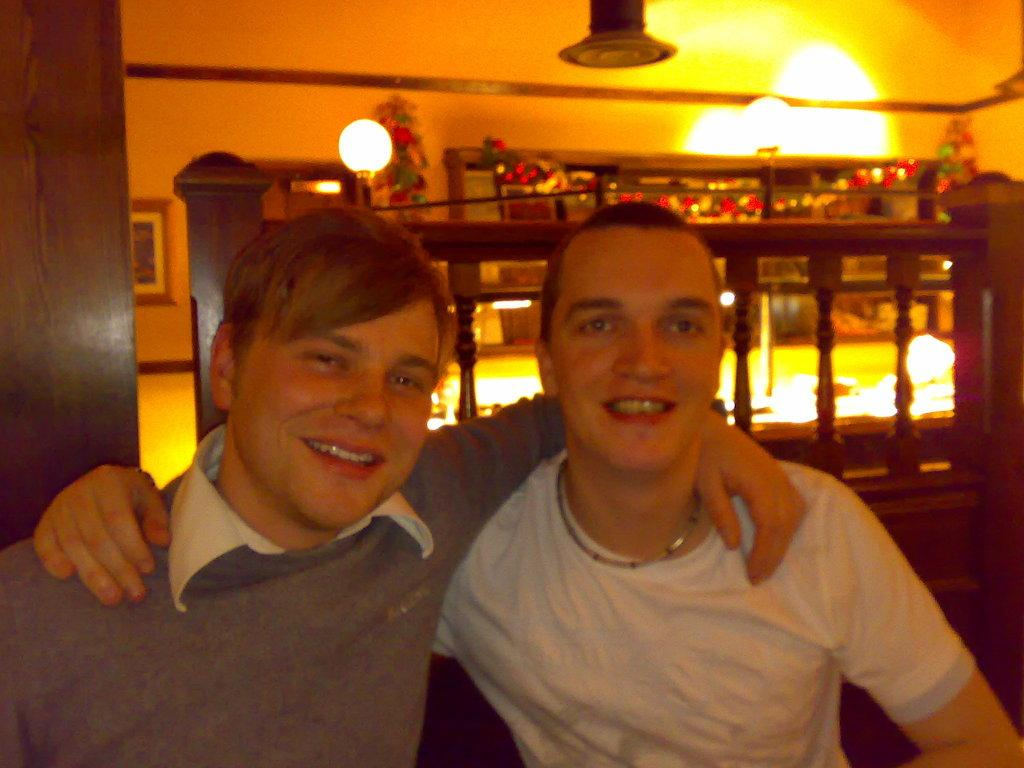How many people are in the image? There are two men in the image. What are the men doing in the image? The men are sitting on chairs. What can be seen in the background of the image? There is a wooden railing, lights, and a wall in the background of the image. What type of corn is being harvested by the crowd in the image? There is no corn or crowd present in the image; it only features two men sitting on chairs. 